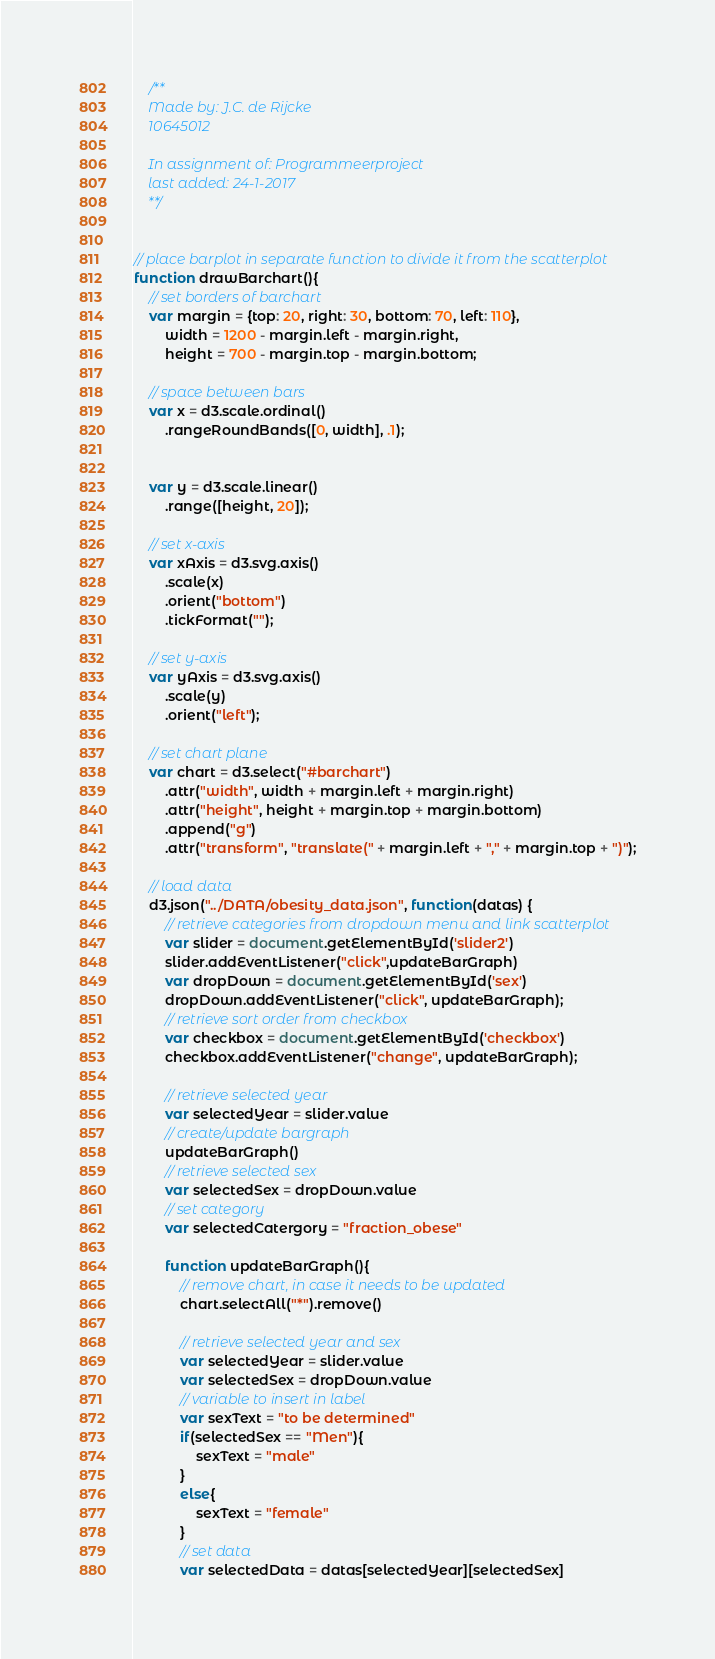Convert code to text. <code><loc_0><loc_0><loc_500><loc_500><_JavaScript_>    /**
    Made by: J.C. de Rijcke
    10645012

    In assignment of: Programmeerproject
    last added: 24-1-2017
    **/


// place barplot in separate function to divide it from the scatterplot
function drawBarchart(){
    // set borders of barchart
    var margin = {top: 20, right: 30, bottom: 70, left: 110},
        width = 1200 - margin.left - margin.right,
        height = 700 - margin.top - margin.bottom;

    // space between bars
    var x = d3.scale.ordinal()
        .rangeRoundBands([0, width], .1);


    var y = d3.scale.linear()
        .range([height, 20]);

    // set x-axis
    var xAxis = d3.svg.axis()
        .scale(x)
        .orient("bottom")
        .tickFormat("");

    // set y-axis
    var yAxis = d3.svg.axis()
        .scale(y)
        .orient("left");

    // set chart plane
    var chart = d3.select("#barchart")
        .attr("width", width + margin.left + margin.right)
        .attr("height", height + margin.top + margin.bottom)
        .append("g")
        .attr("transform", "translate(" + margin.left + "," + margin.top + ")");

    // load data
    d3.json("../DATA/obesity_data.json", function(datas) {
        // retrieve categories from dropdown menu and link scatterplot
        var slider = document.getElementById('slider2')
        slider.addEventListener("click",updateBarGraph)
        var dropDown = document.getElementById('sex')
        dropDown.addEventListener("click", updateBarGraph);
        // retrieve sort order from checkbox
        var checkbox = document.getElementById('checkbox')
        checkbox.addEventListener("change", updateBarGraph);

        // retrieve selected year
        var selectedYear = slider.value
        // create/update bargraph
        updateBarGraph()
        // retrieve selected sex
        var selectedSex = dropDown.value
        // set category
        var selectedCatergory = "fraction_obese"

        function updateBarGraph(){
            // remove chart, in case it needs to be updated
            chart.selectAll("*").remove()

            // retrieve selected year and sex
            var selectedYear = slider.value
            var selectedSex = dropDown.value
            // variable to insert in label
            var sexText = "to be determined"
            if(selectedSex == "Men"){
                sexText = "male"
            }
            else{
                sexText = "female"
            }
            // set data
            var selectedData = datas[selectedYear][selectedSex]</code> 